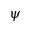Convert formula to latex. <formula><loc_0><loc_0><loc_500><loc_500>\psi</formula> 